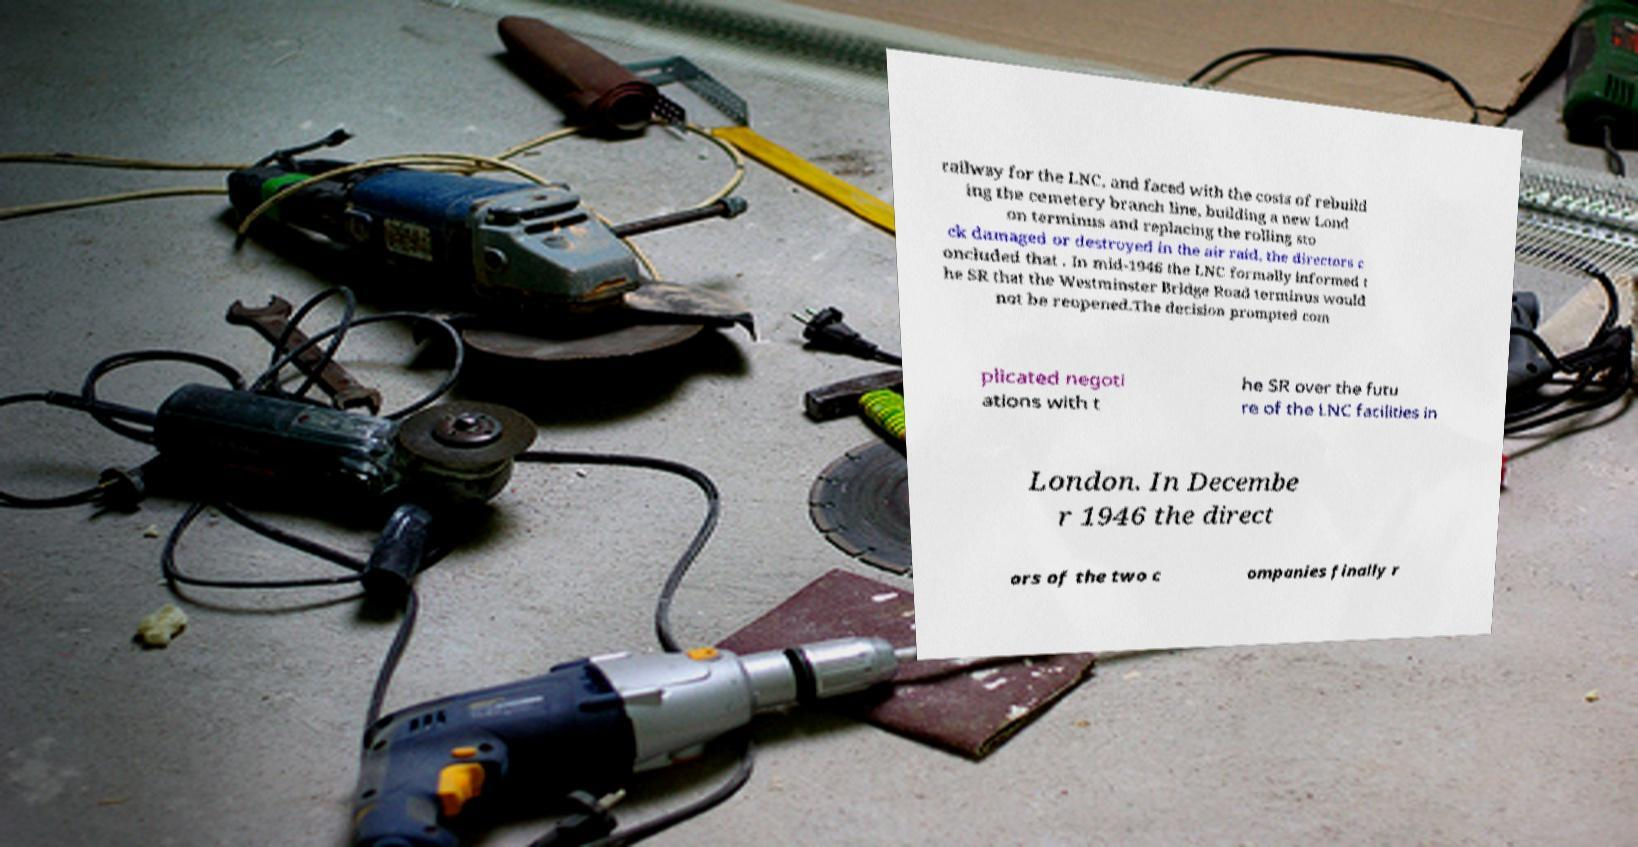I need the written content from this picture converted into text. Can you do that? railway for the LNC, and faced with the costs of rebuild ing the cemetery branch line, building a new Lond on terminus and replacing the rolling sto ck damaged or destroyed in the air raid, the directors c oncluded that . In mid-1946 the LNC formally informed t he SR that the Westminster Bridge Road terminus would not be reopened.The decision prompted com plicated negoti ations with t he SR over the futu re of the LNC facilities in London. In Decembe r 1946 the direct ors of the two c ompanies finally r 